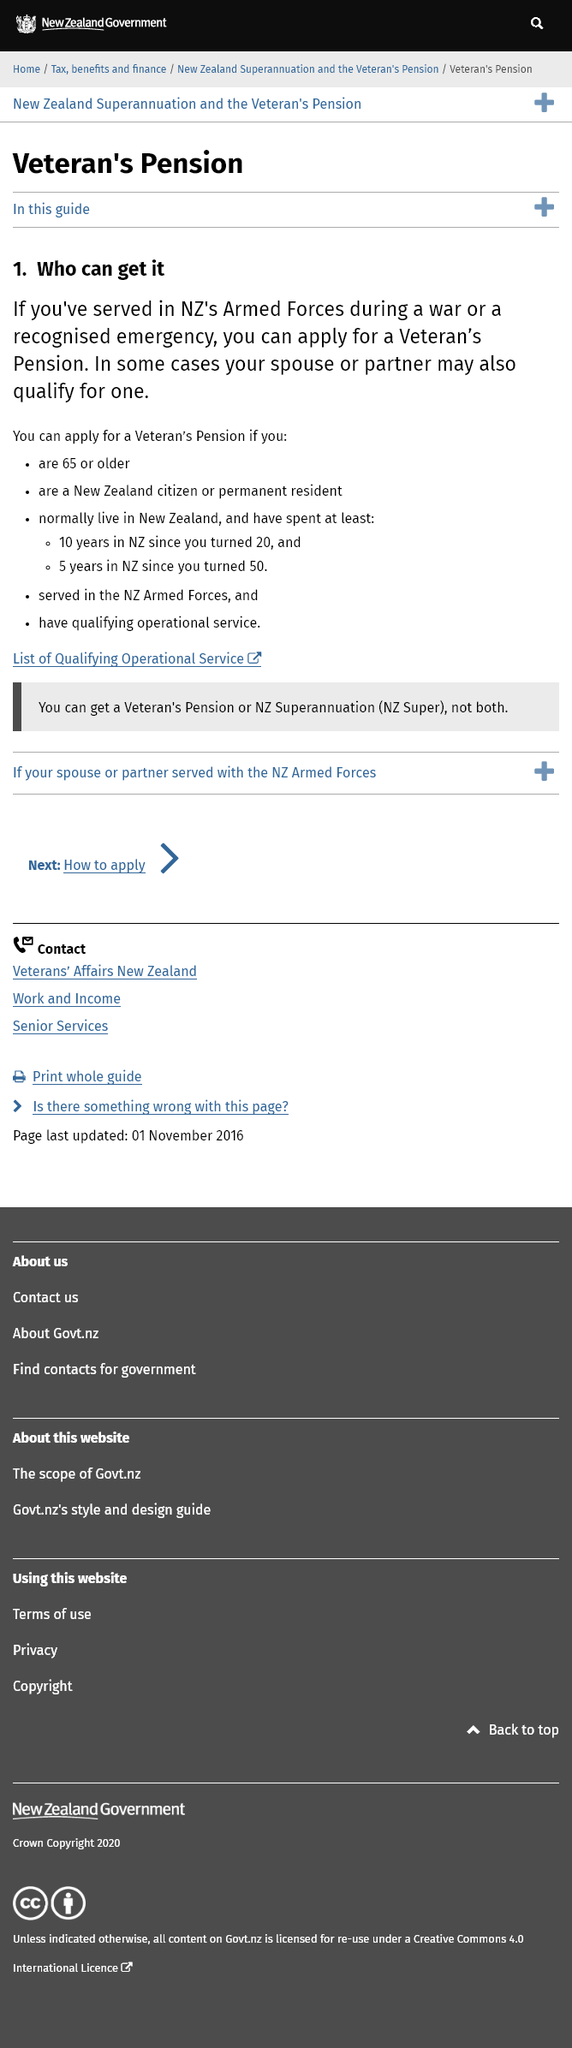Specify some key components in this picture. To be eligible to apply for a Veteran's Pension, you must be at least 65 years of age or older. In order to qualify for a Veteran's Pension in New Zealand, you must have spent at least 5 years in the country since turning 50. In order to qualify for a Veteran's Pension in New Zealand, you must have spent at least 10 years living in the country since turning 20 years old. 